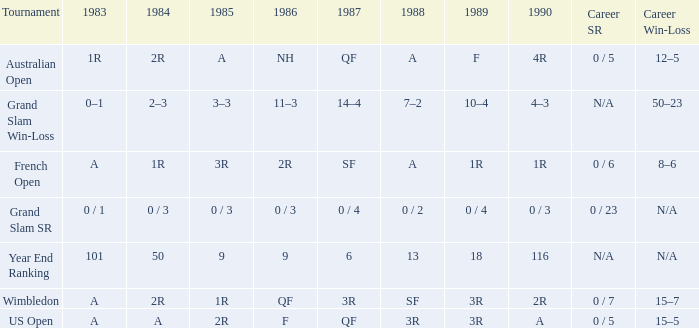What is the 1987 results when the results of 1989 is 3R, and the 1986 results is F? QF. 